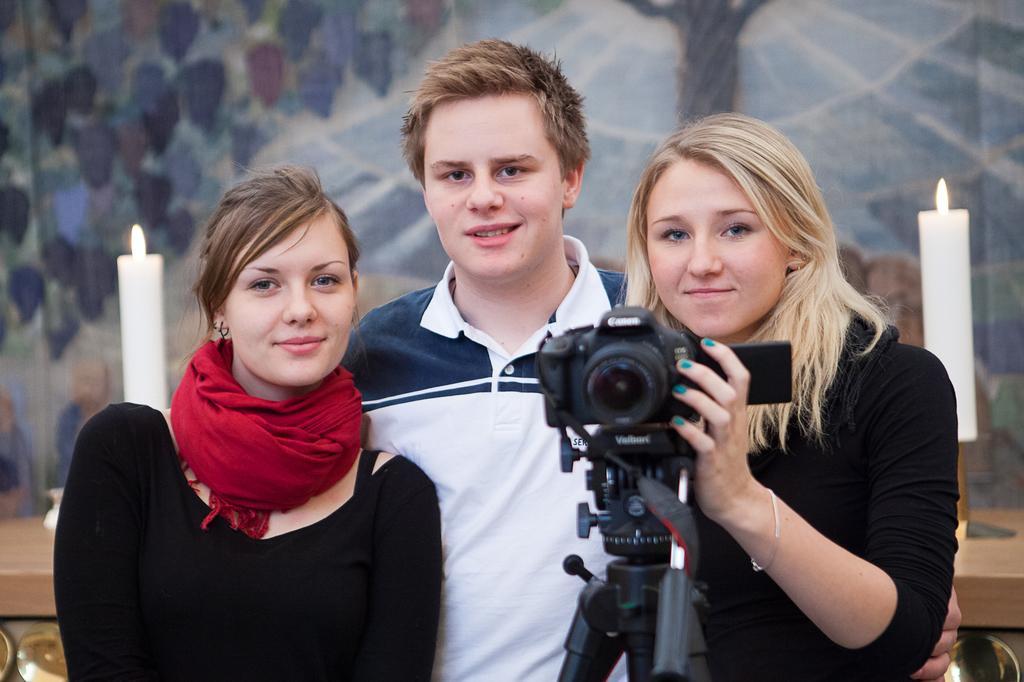Could you give a brief overview of what you see in this image? In this image, there are three persons standing. two of them are women's and one is man. she is holding a camera in her hand. In the background bottom of the image, there is a table on which white color candle is kept. In the background, there is a wall on which painting is made. The picture looks as if it is taken during sunny day. 